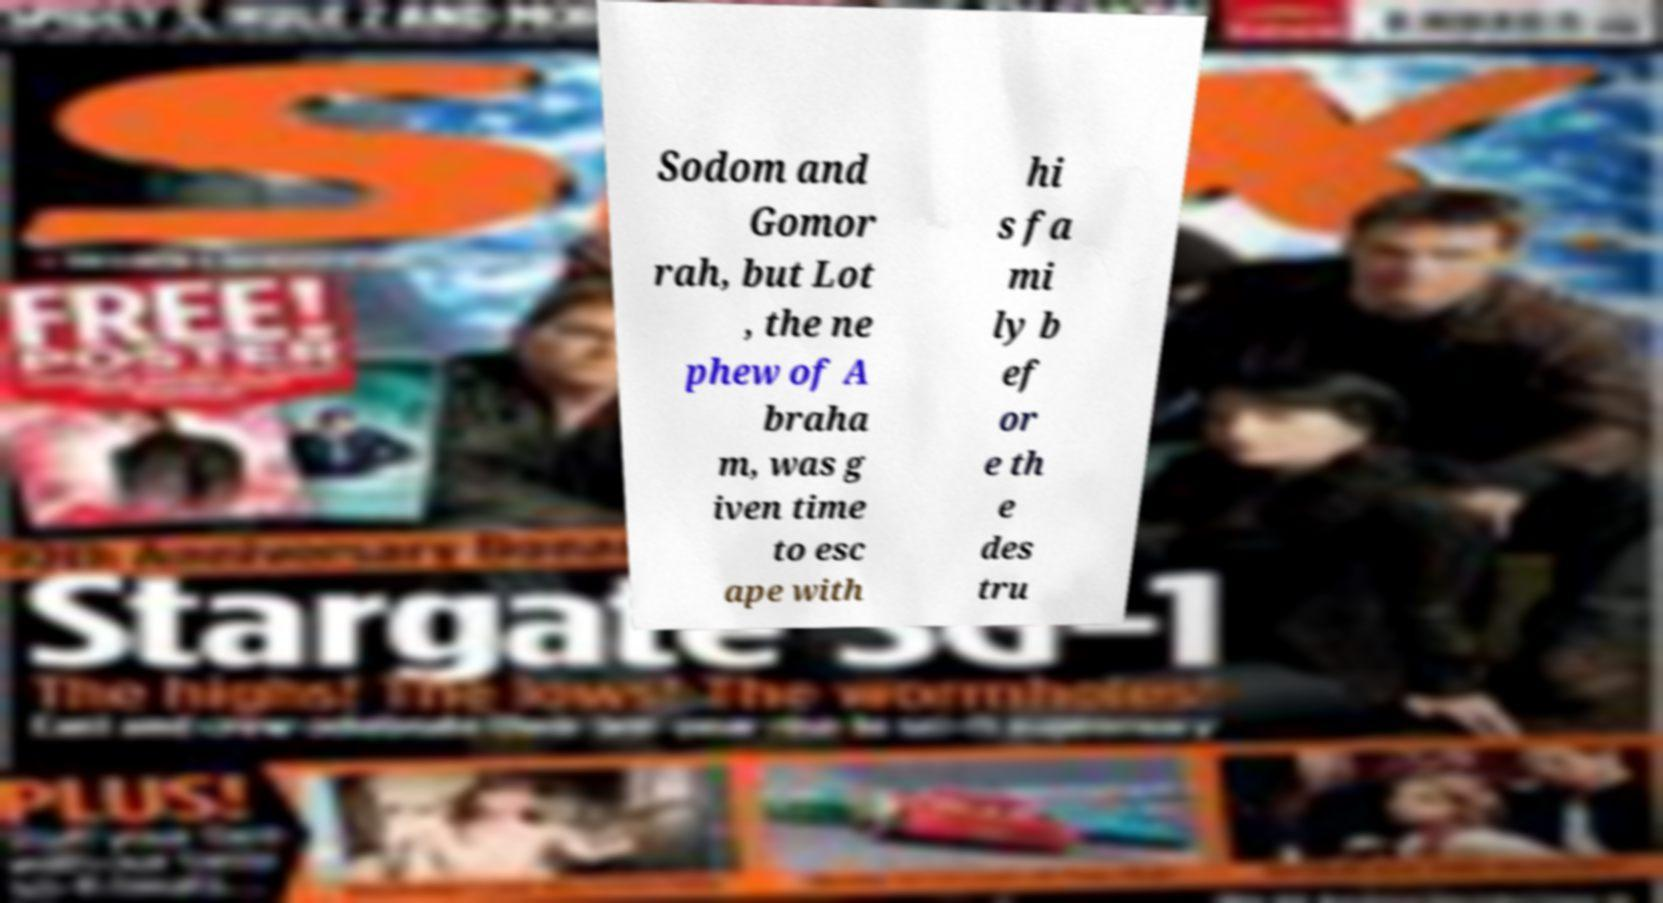Could you assist in decoding the text presented in this image and type it out clearly? Sodom and Gomor rah, but Lot , the ne phew of A braha m, was g iven time to esc ape with hi s fa mi ly b ef or e th e des tru 